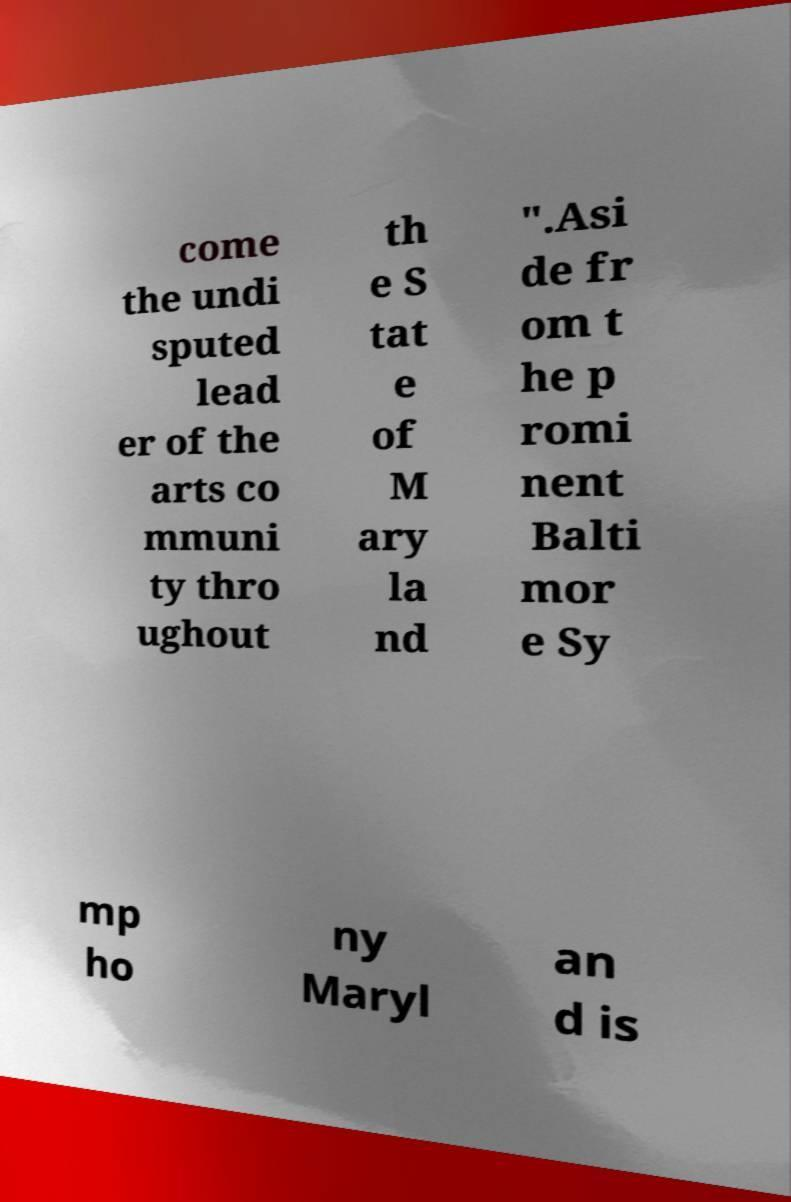Please read and relay the text visible in this image. What does it say? come the undi sputed lead er of the arts co mmuni ty thro ughout th e S tat e of M ary la nd ".Asi de fr om t he p romi nent Balti mor e Sy mp ho ny Maryl an d is 